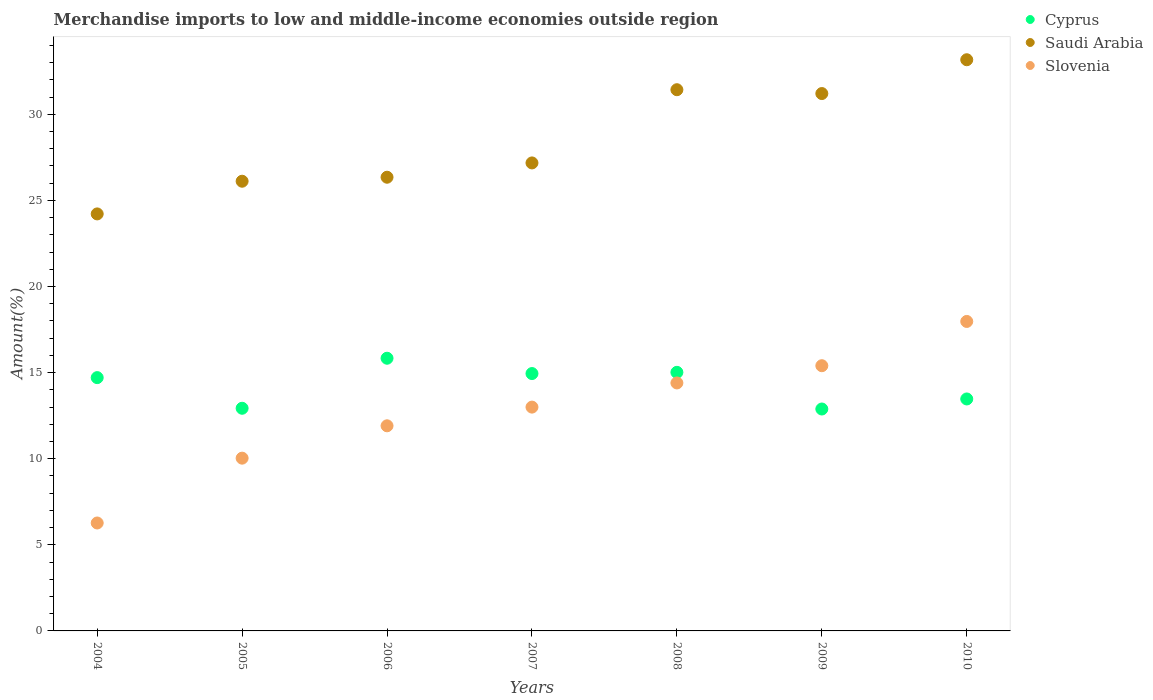Is the number of dotlines equal to the number of legend labels?
Keep it short and to the point. Yes. What is the percentage of amount earned from merchandise imports in Cyprus in 2008?
Give a very brief answer. 15.01. Across all years, what is the maximum percentage of amount earned from merchandise imports in Cyprus?
Your answer should be compact. 15.83. Across all years, what is the minimum percentage of amount earned from merchandise imports in Saudi Arabia?
Offer a very short reply. 24.21. What is the total percentage of amount earned from merchandise imports in Cyprus in the graph?
Provide a succinct answer. 99.78. What is the difference between the percentage of amount earned from merchandise imports in Saudi Arabia in 2008 and that in 2009?
Your answer should be very brief. 0.22. What is the difference between the percentage of amount earned from merchandise imports in Saudi Arabia in 2006 and the percentage of amount earned from merchandise imports in Cyprus in 2008?
Offer a very short reply. 11.33. What is the average percentage of amount earned from merchandise imports in Slovenia per year?
Offer a terse response. 12.71. In the year 2009, what is the difference between the percentage of amount earned from merchandise imports in Slovenia and percentage of amount earned from merchandise imports in Cyprus?
Ensure brevity in your answer.  2.51. What is the ratio of the percentage of amount earned from merchandise imports in Cyprus in 2006 to that in 2009?
Provide a succinct answer. 1.23. Is the percentage of amount earned from merchandise imports in Saudi Arabia in 2007 less than that in 2009?
Ensure brevity in your answer.  Yes. Is the difference between the percentage of amount earned from merchandise imports in Slovenia in 2007 and 2009 greater than the difference between the percentage of amount earned from merchandise imports in Cyprus in 2007 and 2009?
Your response must be concise. No. What is the difference between the highest and the second highest percentage of amount earned from merchandise imports in Slovenia?
Provide a short and direct response. 2.57. What is the difference between the highest and the lowest percentage of amount earned from merchandise imports in Slovenia?
Ensure brevity in your answer.  11.7. In how many years, is the percentage of amount earned from merchandise imports in Cyprus greater than the average percentage of amount earned from merchandise imports in Cyprus taken over all years?
Ensure brevity in your answer.  4. Is the percentage of amount earned from merchandise imports in Saudi Arabia strictly greater than the percentage of amount earned from merchandise imports in Slovenia over the years?
Keep it short and to the point. Yes. Is the percentage of amount earned from merchandise imports in Cyprus strictly less than the percentage of amount earned from merchandise imports in Slovenia over the years?
Keep it short and to the point. No. How many dotlines are there?
Your answer should be compact. 3. How many years are there in the graph?
Give a very brief answer. 7. Does the graph contain any zero values?
Give a very brief answer. No. Does the graph contain grids?
Your response must be concise. No. How many legend labels are there?
Ensure brevity in your answer.  3. How are the legend labels stacked?
Your answer should be compact. Vertical. What is the title of the graph?
Offer a very short reply. Merchandise imports to low and middle-income economies outside region. Does "Ukraine" appear as one of the legend labels in the graph?
Provide a short and direct response. No. What is the label or title of the Y-axis?
Your answer should be very brief. Amount(%). What is the Amount(%) of Cyprus in 2004?
Ensure brevity in your answer.  14.71. What is the Amount(%) in Saudi Arabia in 2004?
Your response must be concise. 24.21. What is the Amount(%) of Slovenia in 2004?
Offer a terse response. 6.27. What is the Amount(%) of Cyprus in 2005?
Provide a succinct answer. 12.93. What is the Amount(%) in Saudi Arabia in 2005?
Provide a succinct answer. 26.11. What is the Amount(%) in Slovenia in 2005?
Ensure brevity in your answer.  10.03. What is the Amount(%) of Cyprus in 2006?
Provide a succinct answer. 15.83. What is the Amount(%) of Saudi Arabia in 2006?
Your response must be concise. 26.34. What is the Amount(%) of Slovenia in 2006?
Ensure brevity in your answer.  11.91. What is the Amount(%) of Cyprus in 2007?
Provide a succinct answer. 14.94. What is the Amount(%) of Saudi Arabia in 2007?
Offer a very short reply. 27.17. What is the Amount(%) of Slovenia in 2007?
Your response must be concise. 13. What is the Amount(%) of Cyprus in 2008?
Your answer should be very brief. 15.01. What is the Amount(%) in Saudi Arabia in 2008?
Make the answer very short. 31.42. What is the Amount(%) in Slovenia in 2008?
Make the answer very short. 14.4. What is the Amount(%) of Cyprus in 2009?
Offer a very short reply. 12.89. What is the Amount(%) of Saudi Arabia in 2009?
Offer a very short reply. 31.2. What is the Amount(%) of Slovenia in 2009?
Give a very brief answer. 15.4. What is the Amount(%) of Cyprus in 2010?
Make the answer very short. 13.47. What is the Amount(%) in Saudi Arabia in 2010?
Provide a short and direct response. 33.17. What is the Amount(%) in Slovenia in 2010?
Your response must be concise. 17.97. Across all years, what is the maximum Amount(%) in Cyprus?
Your answer should be compact. 15.83. Across all years, what is the maximum Amount(%) in Saudi Arabia?
Offer a terse response. 33.17. Across all years, what is the maximum Amount(%) of Slovenia?
Provide a short and direct response. 17.97. Across all years, what is the minimum Amount(%) of Cyprus?
Ensure brevity in your answer.  12.89. Across all years, what is the minimum Amount(%) in Saudi Arabia?
Offer a very short reply. 24.21. Across all years, what is the minimum Amount(%) in Slovenia?
Provide a short and direct response. 6.27. What is the total Amount(%) of Cyprus in the graph?
Your answer should be compact. 99.78. What is the total Amount(%) of Saudi Arabia in the graph?
Give a very brief answer. 199.64. What is the total Amount(%) in Slovenia in the graph?
Offer a very short reply. 88.97. What is the difference between the Amount(%) in Cyprus in 2004 and that in 2005?
Offer a terse response. 1.78. What is the difference between the Amount(%) of Saudi Arabia in 2004 and that in 2005?
Your response must be concise. -1.9. What is the difference between the Amount(%) in Slovenia in 2004 and that in 2005?
Your response must be concise. -3.76. What is the difference between the Amount(%) of Cyprus in 2004 and that in 2006?
Provide a succinct answer. -1.13. What is the difference between the Amount(%) in Saudi Arabia in 2004 and that in 2006?
Offer a terse response. -2.13. What is the difference between the Amount(%) of Slovenia in 2004 and that in 2006?
Give a very brief answer. -5.64. What is the difference between the Amount(%) of Cyprus in 2004 and that in 2007?
Keep it short and to the point. -0.24. What is the difference between the Amount(%) of Saudi Arabia in 2004 and that in 2007?
Provide a succinct answer. -2.96. What is the difference between the Amount(%) in Slovenia in 2004 and that in 2007?
Your answer should be compact. -6.73. What is the difference between the Amount(%) of Cyprus in 2004 and that in 2008?
Keep it short and to the point. -0.31. What is the difference between the Amount(%) of Saudi Arabia in 2004 and that in 2008?
Offer a terse response. -7.21. What is the difference between the Amount(%) of Slovenia in 2004 and that in 2008?
Offer a terse response. -8.13. What is the difference between the Amount(%) in Cyprus in 2004 and that in 2009?
Keep it short and to the point. 1.82. What is the difference between the Amount(%) of Saudi Arabia in 2004 and that in 2009?
Your answer should be compact. -6.99. What is the difference between the Amount(%) in Slovenia in 2004 and that in 2009?
Keep it short and to the point. -9.13. What is the difference between the Amount(%) of Cyprus in 2004 and that in 2010?
Offer a terse response. 1.24. What is the difference between the Amount(%) of Saudi Arabia in 2004 and that in 2010?
Your answer should be very brief. -8.95. What is the difference between the Amount(%) of Slovenia in 2004 and that in 2010?
Keep it short and to the point. -11.7. What is the difference between the Amount(%) of Cyprus in 2005 and that in 2006?
Keep it short and to the point. -2.91. What is the difference between the Amount(%) in Saudi Arabia in 2005 and that in 2006?
Provide a short and direct response. -0.23. What is the difference between the Amount(%) in Slovenia in 2005 and that in 2006?
Provide a succinct answer. -1.88. What is the difference between the Amount(%) of Cyprus in 2005 and that in 2007?
Give a very brief answer. -2.02. What is the difference between the Amount(%) in Saudi Arabia in 2005 and that in 2007?
Your response must be concise. -1.06. What is the difference between the Amount(%) in Slovenia in 2005 and that in 2007?
Make the answer very short. -2.96. What is the difference between the Amount(%) of Cyprus in 2005 and that in 2008?
Offer a very short reply. -2.09. What is the difference between the Amount(%) in Saudi Arabia in 2005 and that in 2008?
Offer a very short reply. -5.31. What is the difference between the Amount(%) of Slovenia in 2005 and that in 2008?
Keep it short and to the point. -4.37. What is the difference between the Amount(%) of Cyprus in 2005 and that in 2009?
Your response must be concise. 0.04. What is the difference between the Amount(%) in Saudi Arabia in 2005 and that in 2009?
Offer a terse response. -5.09. What is the difference between the Amount(%) in Slovenia in 2005 and that in 2009?
Make the answer very short. -5.37. What is the difference between the Amount(%) in Cyprus in 2005 and that in 2010?
Provide a short and direct response. -0.54. What is the difference between the Amount(%) of Saudi Arabia in 2005 and that in 2010?
Provide a succinct answer. -7.05. What is the difference between the Amount(%) in Slovenia in 2005 and that in 2010?
Give a very brief answer. -7.94. What is the difference between the Amount(%) of Cyprus in 2006 and that in 2007?
Your answer should be very brief. 0.89. What is the difference between the Amount(%) of Saudi Arabia in 2006 and that in 2007?
Provide a short and direct response. -0.83. What is the difference between the Amount(%) in Slovenia in 2006 and that in 2007?
Offer a very short reply. -1.09. What is the difference between the Amount(%) in Cyprus in 2006 and that in 2008?
Your answer should be compact. 0.82. What is the difference between the Amount(%) of Saudi Arabia in 2006 and that in 2008?
Offer a very short reply. -5.08. What is the difference between the Amount(%) in Slovenia in 2006 and that in 2008?
Provide a succinct answer. -2.49. What is the difference between the Amount(%) in Cyprus in 2006 and that in 2009?
Offer a very short reply. 2.95. What is the difference between the Amount(%) in Saudi Arabia in 2006 and that in 2009?
Offer a very short reply. -4.86. What is the difference between the Amount(%) in Slovenia in 2006 and that in 2009?
Give a very brief answer. -3.49. What is the difference between the Amount(%) in Cyprus in 2006 and that in 2010?
Keep it short and to the point. 2.36. What is the difference between the Amount(%) in Saudi Arabia in 2006 and that in 2010?
Provide a short and direct response. -6.82. What is the difference between the Amount(%) of Slovenia in 2006 and that in 2010?
Your answer should be compact. -6.06. What is the difference between the Amount(%) of Cyprus in 2007 and that in 2008?
Offer a terse response. -0.07. What is the difference between the Amount(%) of Saudi Arabia in 2007 and that in 2008?
Your answer should be compact. -4.25. What is the difference between the Amount(%) of Slovenia in 2007 and that in 2008?
Offer a terse response. -1.4. What is the difference between the Amount(%) of Cyprus in 2007 and that in 2009?
Ensure brevity in your answer.  2.06. What is the difference between the Amount(%) of Saudi Arabia in 2007 and that in 2009?
Your answer should be very brief. -4.03. What is the difference between the Amount(%) in Slovenia in 2007 and that in 2009?
Give a very brief answer. -2.4. What is the difference between the Amount(%) of Cyprus in 2007 and that in 2010?
Offer a very short reply. 1.48. What is the difference between the Amount(%) in Saudi Arabia in 2007 and that in 2010?
Make the answer very short. -5.99. What is the difference between the Amount(%) in Slovenia in 2007 and that in 2010?
Offer a very short reply. -4.97. What is the difference between the Amount(%) of Cyprus in 2008 and that in 2009?
Your answer should be very brief. 2.13. What is the difference between the Amount(%) of Saudi Arabia in 2008 and that in 2009?
Ensure brevity in your answer.  0.22. What is the difference between the Amount(%) in Slovenia in 2008 and that in 2009?
Keep it short and to the point. -1. What is the difference between the Amount(%) in Cyprus in 2008 and that in 2010?
Your answer should be very brief. 1.55. What is the difference between the Amount(%) in Saudi Arabia in 2008 and that in 2010?
Your answer should be very brief. -1.74. What is the difference between the Amount(%) of Slovenia in 2008 and that in 2010?
Offer a terse response. -3.57. What is the difference between the Amount(%) in Cyprus in 2009 and that in 2010?
Provide a succinct answer. -0.58. What is the difference between the Amount(%) in Saudi Arabia in 2009 and that in 2010?
Make the answer very short. -1.96. What is the difference between the Amount(%) in Slovenia in 2009 and that in 2010?
Offer a very short reply. -2.57. What is the difference between the Amount(%) of Cyprus in 2004 and the Amount(%) of Saudi Arabia in 2005?
Your answer should be compact. -11.4. What is the difference between the Amount(%) in Cyprus in 2004 and the Amount(%) in Slovenia in 2005?
Offer a terse response. 4.68. What is the difference between the Amount(%) of Saudi Arabia in 2004 and the Amount(%) of Slovenia in 2005?
Your answer should be compact. 14.18. What is the difference between the Amount(%) in Cyprus in 2004 and the Amount(%) in Saudi Arabia in 2006?
Offer a very short reply. -11.64. What is the difference between the Amount(%) in Cyprus in 2004 and the Amount(%) in Slovenia in 2006?
Offer a very short reply. 2.8. What is the difference between the Amount(%) of Saudi Arabia in 2004 and the Amount(%) of Slovenia in 2006?
Ensure brevity in your answer.  12.3. What is the difference between the Amount(%) in Cyprus in 2004 and the Amount(%) in Saudi Arabia in 2007?
Make the answer very short. -12.47. What is the difference between the Amount(%) in Cyprus in 2004 and the Amount(%) in Slovenia in 2007?
Keep it short and to the point. 1.71. What is the difference between the Amount(%) of Saudi Arabia in 2004 and the Amount(%) of Slovenia in 2007?
Offer a very short reply. 11.22. What is the difference between the Amount(%) in Cyprus in 2004 and the Amount(%) in Saudi Arabia in 2008?
Provide a short and direct response. -16.72. What is the difference between the Amount(%) in Cyprus in 2004 and the Amount(%) in Slovenia in 2008?
Your answer should be compact. 0.31. What is the difference between the Amount(%) in Saudi Arabia in 2004 and the Amount(%) in Slovenia in 2008?
Provide a short and direct response. 9.82. What is the difference between the Amount(%) in Cyprus in 2004 and the Amount(%) in Saudi Arabia in 2009?
Your answer should be compact. -16.49. What is the difference between the Amount(%) in Cyprus in 2004 and the Amount(%) in Slovenia in 2009?
Give a very brief answer. -0.69. What is the difference between the Amount(%) of Saudi Arabia in 2004 and the Amount(%) of Slovenia in 2009?
Keep it short and to the point. 8.81. What is the difference between the Amount(%) in Cyprus in 2004 and the Amount(%) in Saudi Arabia in 2010?
Ensure brevity in your answer.  -18.46. What is the difference between the Amount(%) in Cyprus in 2004 and the Amount(%) in Slovenia in 2010?
Make the answer very short. -3.26. What is the difference between the Amount(%) in Saudi Arabia in 2004 and the Amount(%) in Slovenia in 2010?
Keep it short and to the point. 6.24. What is the difference between the Amount(%) in Cyprus in 2005 and the Amount(%) in Saudi Arabia in 2006?
Ensure brevity in your answer.  -13.42. What is the difference between the Amount(%) of Cyprus in 2005 and the Amount(%) of Slovenia in 2006?
Ensure brevity in your answer.  1.02. What is the difference between the Amount(%) in Saudi Arabia in 2005 and the Amount(%) in Slovenia in 2006?
Ensure brevity in your answer.  14.2. What is the difference between the Amount(%) of Cyprus in 2005 and the Amount(%) of Saudi Arabia in 2007?
Provide a short and direct response. -14.25. What is the difference between the Amount(%) in Cyprus in 2005 and the Amount(%) in Slovenia in 2007?
Keep it short and to the point. -0.07. What is the difference between the Amount(%) in Saudi Arabia in 2005 and the Amount(%) in Slovenia in 2007?
Offer a terse response. 13.12. What is the difference between the Amount(%) of Cyprus in 2005 and the Amount(%) of Saudi Arabia in 2008?
Your response must be concise. -18.5. What is the difference between the Amount(%) of Cyprus in 2005 and the Amount(%) of Slovenia in 2008?
Your response must be concise. -1.47. What is the difference between the Amount(%) in Saudi Arabia in 2005 and the Amount(%) in Slovenia in 2008?
Give a very brief answer. 11.71. What is the difference between the Amount(%) in Cyprus in 2005 and the Amount(%) in Saudi Arabia in 2009?
Your answer should be very brief. -18.27. What is the difference between the Amount(%) in Cyprus in 2005 and the Amount(%) in Slovenia in 2009?
Your response must be concise. -2.47. What is the difference between the Amount(%) of Saudi Arabia in 2005 and the Amount(%) of Slovenia in 2009?
Offer a terse response. 10.71. What is the difference between the Amount(%) in Cyprus in 2005 and the Amount(%) in Saudi Arabia in 2010?
Ensure brevity in your answer.  -20.24. What is the difference between the Amount(%) in Cyprus in 2005 and the Amount(%) in Slovenia in 2010?
Keep it short and to the point. -5.04. What is the difference between the Amount(%) of Saudi Arabia in 2005 and the Amount(%) of Slovenia in 2010?
Make the answer very short. 8.14. What is the difference between the Amount(%) in Cyprus in 2006 and the Amount(%) in Saudi Arabia in 2007?
Provide a short and direct response. -11.34. What is the difference between the Amount(%) in Cyprus in 2006 and the Amount(%) in Slovenia in 2007?
Offer a terse response. 2.84. What is the difference between the Amount(%) in Saudi Arabia in 2006 and the Amount(%) in Slovenia in 2007?
Ensure brevity in your answer.  13.35. What is the difference between the Amount(%) of Cyprus in 2006 and the Amount(%) of Saudi Arabia in 2008?
Provide a succinct answer. -15.59. What is the difference between the Amount(%) of Cyprus in 2006 and the Amount(%) of Slovenia in 2008?
Ensure brevity in your answer.  1.44. What is the difference between the Amount(%) in Saudi Arabia in 2006 and the Amount(%) in Slovenia in 2008?
Provide a succinct answer. 11.95. What is the difference between the Amount(%) in Cyprus in 2006 and the Amount(%) in Saudi Arabia in 2009?
Your answer should be very brief. -15.37. What is the difference between the Amount(%) in Cyprus in 2006 and the Amount(%) in Slovenia in 2009?
Provide a succinct answer. 0.43. What is the difference between the Amount(%) in Saudi Arabia in 2006 and the Amount(%) in Slovenia in 2009?
Ensure brevity in your answer.  10.94. What is the difference between the Amount(%) in Cyprus in 2006 and the Amount(%) in Saudi Arabia in 2010?
Provide a short and direct response. -17.33. What is the difference between the Amount(%) of Cyprus in 2006 and the Amount(%) of Slovenia in 2010?
Offer a very short reply. -2.14. What is the difference between the Amount(%) in Saudi Arabia in 2006 and the Amount(%) in Slovenia in 2010?
Keep it short and to the point. 8.37. What is the difference between the Amount(%) of Cyprus in 2007 and the Amount(%) of Saudi Arabia in 2008?
Your answer should be very brief. -16.48. What is the difference between the Amount(%) in Cyprus in 2007 and the Amount(%) in Slovenia in 2008?
Offer a terse response. 0.55. What is the difference between the Amount(%) of Saudi Arabia in 2007 and the Amount(%) of Slovenia in 2008?
Ensure brevity in your answer.  12.78. What is the difference between the Amount(%) of Cyprus in 2007 and the Amount(%) of Saudi Arabia in 2009?
Offer a terse response. -16.26. What is the difference between the Amount(%) in Cyprus in 2007 and the Amount(%) in Slovenia in 2009?
Keep it short and to the point. -0.46. What is the difference between the Amount(%) of Saudi Arabia in 2007 and the Amount(%) of Slovenia in 2009?
Give a very brief answer. 11.77. What is the difference between the Amount(%) of Cyprus in 2007 and the Amount(%) of Saudi Arabia in 2010?
Make the answer very short. -18.22. What is the difference between the Amount(%) in Cyprus in 2007 and the Amount(%) in Slovenia in 2010?
Offer a very short reply. -3.03. What is the difference between the Amount(%) of Saudi Arabia in 2007 and the Amount(%) of Slovenia in 2010?
Your answer should be compact. 9.2. What is the difference between the Amount(%) in Cyprus in 2008 and the Amount(%) in Saudi Arabia in 2009?
Keep it short and to the point. -16.19. What is the difference between the Amount(%) in Cyprus in 2008 and the Amount(%) in Slovenia in 2009?
Keep it short and to the point. -0.38. What is the difference between the Amount(%) of Saudi Arabia in 2008 and the Amount(%) of Slovenia in 2009?
Offer a terse response. 16.03. What is the difference between the Amount(%) of Cyprus in 2008 and the Amount(%) of Saudi Arabia in 2010?
Provide a succinct answer. -18.15. What is the difference between the Amount(%) of Cyprus in 2008 and the Amount(%) of Slovenia in 2010?
Your answer should be very brief. -2.95. What is the difference between the Amount(%) of Saudi Arabia in 2008 and the Amount(%) of Slovenia in 2010?
Your answer should be compact. 13.46. What is the difference between the Amount(%) in Cyprus in 2009 and the Amount(%) in Saudi Arabia in 2010?
Make the answer very short. -20.28. What is the difference between the Amount(%) in Cyprus in 2009 and the Amount(%) in Slovenia in 2010?
Provide a succinct answer. -5.08. What is the difference between the Amount(%) in Saudi Arabia in 2009 and the Amount(%) in Slovenia in 2010?
Provide a short and direct response. 13.23. What is the average Amount(%) in Cyprus per year?
Provide a succinct answer. 14.25. What is the average Amount(%) of Saudi Arabia per year?
Make the answer very short. 28.52. What is the average Amount(%) in Slovenia per year?
Your answer should be very brief. 12.71. In the year 2004, what is the difference between the Amount(%) in Cyprus and Amount(%) in Saudi Arabia?
Offer a terse response. -9.51. In the year 2004, what is the difference between the Amount(%) of Cyprus and Amount(%) of Slovenia?
Your answer should be very brief. 8.44. In the year 2004, what is the difference between the Amount(%) of Saudi Arabia and Amount(%) of Slovenia?
Keep it short and to the point. 17.95. In the year 2005, what is the difference between the Amount(%) of Cyprus and Amount(%) of Saudi Arabia?
Your response must be concise. -13.18. In the year 2005, what is the difference between the Amount(%) in Cyprus and Amount(%) in Slovenia?
Make the answer very short. 2.9. In the year 2005, what is the difference between the Amount(%) of Saudi Arabia and Amount(%) of Slovenia?
Ensure brevity in your answer.  16.08. In the year 2006, what is the difference between the Amount(%) in Cyprus and Amount(%) in Saudi Arabia?
Your response must be concise. -10.51. In the year 2006, what is the difference between the Amount(%) in Cyprus and Amount(%) in Slovenia?
Offer a very short reply. 3.92. In the year 2006, what is the difference between the Amount(%) of Saudi Arabia and Amount(%) of Slovenia?
Your answer should be compact. 14.43. In the year 2007, what is the difference between the Amount(%) of Cyprus and Amount(%) of Saudi Arabia?
Keep it short and to the point. -12.23. In the year 2007, what is the difference between the Amount(%) of Cyprus and Amount(%) of Slovenia?
Give a very brief answer. 1.95. In the year 2007, what is the difference between the Amount(%) of Saudi Arabia and Amount(%) of Slovenia?
Provide a short and direct response. 14.18. In the year 2008, what is the difference between the Amount(%) in Cyprus and Amount(%) in Saudi Arabia?
Offer a terse response. -16.41. In the year 2008, what is the difference between the Amount(%) in Cyprus and Amount(%) in Slovenia?
Your answer should be compact. 0.62. In the year 2008, what is the difference between the Amount(%) of Saudi Arabia and Amount(%) of Slovenia?
Give a very brief answer. 17.03. In the year 2009, what is the difference between the Amount(%) in Cyprus and Amount(%) in Saudi Arabia?
Your response must be concise. -18.32. In the year 2009, what is the difference between the Amount(%) of Cyprus and Amount(%) of Slovenia?
Your answer should be very brief. -2.51. In the year 2009, what is the difference between the Amount(%) of Saudi Arabia and Amount(%) of Slovenia?
Your answer should be very brief. 15.8. In the year 2010, what is the difference between the Amount(%) of Cyprus and Amount(%) of Saudi Arabia?
Provide a succinct answer. -19.7. In the year 2010, what is the difference between the Amount(%) in Cyprus and Amount(%) in Slovenia?
Offer a very short reply. -4.5. In the year 2010, what is the difference between the Amount(%) in Saudi Arabia and Amount(%) in Slovenia?
Your response must be concise. 15.2. What is the ratio of the Amount(%) in Cyprus in 2004 to that in 2005?
Provide a short and direct response. 1.14. What is the ratio of the Amount(%) in Saudi Arabia in 2004 to that in 2005?
Ensure brevity in your answer.  0.93. What is the ratio of the Amount(%) in Slovenia in 2004 to that in 2005?
Ensure brevity in your answer.  0.62. What is the ratio of the Amount(%) in Cyprus in 2004 to that in 2006?
Make the answer very short. 0.93. What is the ratio of the Amount(%) in Saudi Arabia in 2004 to that in 2006?
Your response must be concise. 0.92. What is the ratio of the Amount(%) of Slovenia in 2004 to that in 2006?
Provide a short and direct response. 0.53. What is the ratio of the Amount(%) of Cyprus in 2004 to that in 2007?
Offer a very short reply. 0.98. What is the ratio of the Amount(%) in Saudi Arabia in 2004 to that in 2007?
Your answer should be very brief. 0.89. What is the ratio of the Amount(%) of Slovenia in 2004 to that in 2007?
Provide a short and direct response. 0.48. What is the ratio of the Amount(%) of Cyprus in 2004 to that in 2008?
Keep it short and to the point. 0.98. What is the ratio of the Amount(%) of Saudi Arabia in 2004 to that in 2008?
Keep it short and to the point. 0.77. What is the ratio of the Amount(%) in Slovenia in 2004 to that in 2008?
Your response must be concise. 0.44. What is the ratio of the Amount(%) in Cyprus in 2004 to that in 2009?
Keep it short and to the point. 1.14. What is the ratio of the Amount(%) of Saudi Arabia in 2004 to that in 2009?
Provide a succinct answer. 0.78. What is the ratio of the Amount(%) in Slovenia in 2004 to that in 2009?
Offer a very short reply. 0.41. What is the ratio of the Amount(%) of Cyprus in 2004 to that in 2010?
Offer a very short reply. 1.09. What is the ratio of the Amount(%) of Saudi Arabia in 2004 to that in 2010?
Your answer should be very brief. 0.73. What is the ratio of the Amount(%) of Slovenia in 2004 to that in 2010?
Keep it short and to the point. 0.35. What is the ratio of the Amount(%) of Cyprus in 2005 to that in 2006?
Offer a terse response. 0.82. What is the ratio of the Amount(%) in Saudi Arabia in 2005 to that in 2006?
Give a very brief answer. 0.99. What is the ratio of the Amount(%) in Slovenia in 2005 to that in 2006?
Make the answer very short. 0.84. What is the ratio of the Amount(%) of Cyprus in 2005 to that in 2007?
Give a very brief answer. 0.87. What is the ratio of the Amount(%) of Saudi Arabia in 2005 to that in 2007?
Your answer should be very brief. 0.96. What is the ratio of the Amount(%) in Slovenia in 2005 to that in 2007?
Make the answer very short. 0.77. What is the ratio of the Amount(%) of Cyprus in 2005 to that in 2008?
Offer a very short reply. 0.86. What is the ratio of the Amount(%) in Saudi Arabia in 2005 to that in 2008?
Make the answer very short. 0.83. What is the ratio of the Amount(%) of Slovenia in 2005 to that in 2008?
Provide a short and direct response. 0.7. What is the ratio of the Amount(%) of Saudi Arabia in 2005 to that in 2009?
Provide a succinct answer. 0.84. What is the ratio of the Amount(%) of Slovenia in 2005 to that in 2009?
Ensure brevity in your answer.  0.65. What is the ratio of the Amount(%) of Cyprus in 2005 to that in 2010?
Give a very brief answer. 0.96. What is the ratio of the Amount(%) of Saudi Arabia in 2005 to that in 2010?
Your answer should be very brief. 0.79. What is the ratio of the Amount(%) of Slovenia in 2005 to that in 2010?
Ensure brevity in your answer.  0.56. What is the ratio of the Amount(%) in Cyprus in 2006 to that in 2007?
Provide a succinct answer. 1.06. What is the ratio of the Amount(%) in Saudi Arabia in 2006 to that in 2007?
Provide a short and direct response. 0.97. What is the ratio of the Amount(%) in Slovenia in 2006 to that in 2007?
Keep it short and to the point. 0.92. What is the ratio of the Amount(%) of Cyprus in 2006 to that in 2008?
Make the answer very short. 1.05. What is the ratio of the Amount(%) of Saudi Arabia in 2006 to that in 2008?
Offer a very short reply. 0.84. What is the ratio of the Amount(%) in Slovenia in 2006 to that in 2008?
Provide a succinct answer. 0.83. What is the ratio of the Amount(%) of Cyprus in 2006 to that in 2009?
Your response must be concise. 1.23. What is the ratio of the Amount(%) in Saudi Arabia in 2006 to that in 2009?
Ensure brevity in your answer.  0.84. What is the ratio of the Amount(%) of Slovenia in 2006 to that in 2009?
Ensure brevity in your answer.  0.77. What is the ratio of the Amount(%) of Cyprus in 2006 to that in 2010?
Offer a terse response. 1.18. What is the ratio of the Amount(%) of Saudi Arabia in 2006 to that in 2010?
Offer a very short reply. 0.79. What is the ratio of the Amount(%) of Slovenia in 2006 to that in 2010?
Keep it short and to the point. 0.66. What is the ratio of the Amount(%) of Cyprus in 2007 to that in 2008?
Provide a short and direct response. 1. What is the ratio of the Amount(%) of Saudi Arabia in 2007 to that in 2008?
Keep it short and to the point. 0.86. What is the ratio of the Amount(%) in Slovenia in 2007 to that in 2008?
Ensure brevity in your answer.  0.9. What is the ratio of the Amount(%) in Cyprus in 2007 to that in 2009?
Give a very brief answer. 1.16. What is the ratio of the Amount(%) of Saudi Arabia in 2007 to that in 2009?
Your answer should be very brief. 0.87. What is the ratio of the Amount(%) of Slovenia in 2007 to that in 2009?
Your response must be concise. 0.84. What is the ratio of the Amount(%) in Cyprus in 2007 to that in 2010?
Provide a succinct answer. 1.11. What is the ratio of the Amount(%) in Saudi Arabia in 2007 to that in 2010?
Provide a short and direct response. 0.82. What is the ratio of the Amount(%) of Slovenia in 2007 to that in 2010?
Your response must be concise. 0.72. What is the ratio of the Amount(%) in Cyprus in 2008 to that in 2009?
Provide a succinct answer. 1.17. What is the ratio of the Amount(%) of Saudi Arabia in 2008 to that in 2009?
Offer a very short reply. 1.01. What is the ratio of the Amount(%) in Slovenia in 2008 to that in 2009?
Provide a short and direct response. 0.94. What is the ratio of the Amount(%) of Cyprus in 2008 to that in 2010?
Provide a short and direct response. 1.11. What is the ratio of the Amount(%) of Saudi Arabia in 2008 to that in 2010?
Provide a succinct answer. 0.95. What is the ratio of the Amount(%) in Slovenia in 2008 to that in 2010?
Offer a terse response. 0.8. What is the ratio of the Amount(%) of Cyprus in 2009 to that in 2010?
Your response must be concise. 0.96. What is the ratio of the Amount(%) of Saudi Arabia in 2009 to that in 2010?
Give a very brief answer. 0.94. What is the ratio of the Amount(%) of Slovenia in 2009 to that in 2010?
Ensure brevity in your answer.  0.86. What is the difference between the highest and the second highest Amount(%) in Cyprus?
Keep it short and to the point. 0.82. What is the difference between the highest and the second highest Amount(%) in Saudi Arabia?
Your answer should be compact. 1.74. What is the difference between the highest and the second highest Amount(%) of Slovenia?
Your answer should be very brief. 2.57. What is the difference between the highest and the lowest Amount(%) in Cyprus?
Give a very brief answer. 2.95. What is the difference between the highest and the lowest Amount(%) in Saudi Arabia?
Your answer should be compact. 8.95. What is the difference between the highest and the lowest Amount(%) of Slovenia?
Provide a succinct answer. 11.7. 